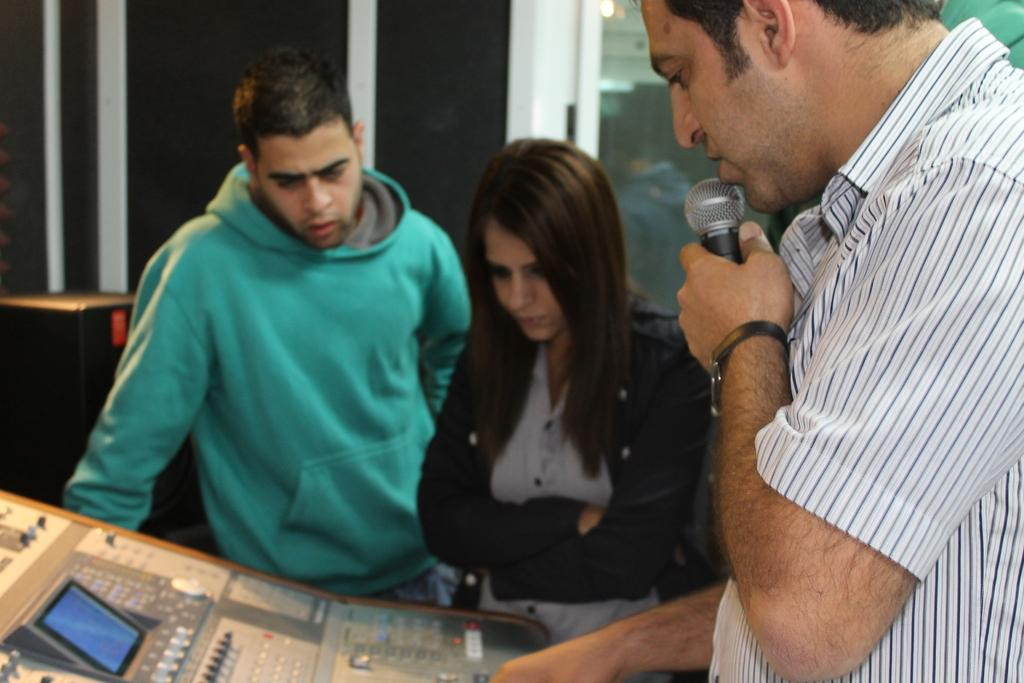What is the man on the right side of the image doing? The man is standing on the right side of the image and holding a mic. Who is near the man in the image? There are two people next to the man in the image. What is located at the bottom of the image? There is a table at the bottom of the image. What can be seen in the background of the image? There is a wall in the background of the image. Can you see the man offering a thread to the audience in the image? There is no thread or audience present in the image. 